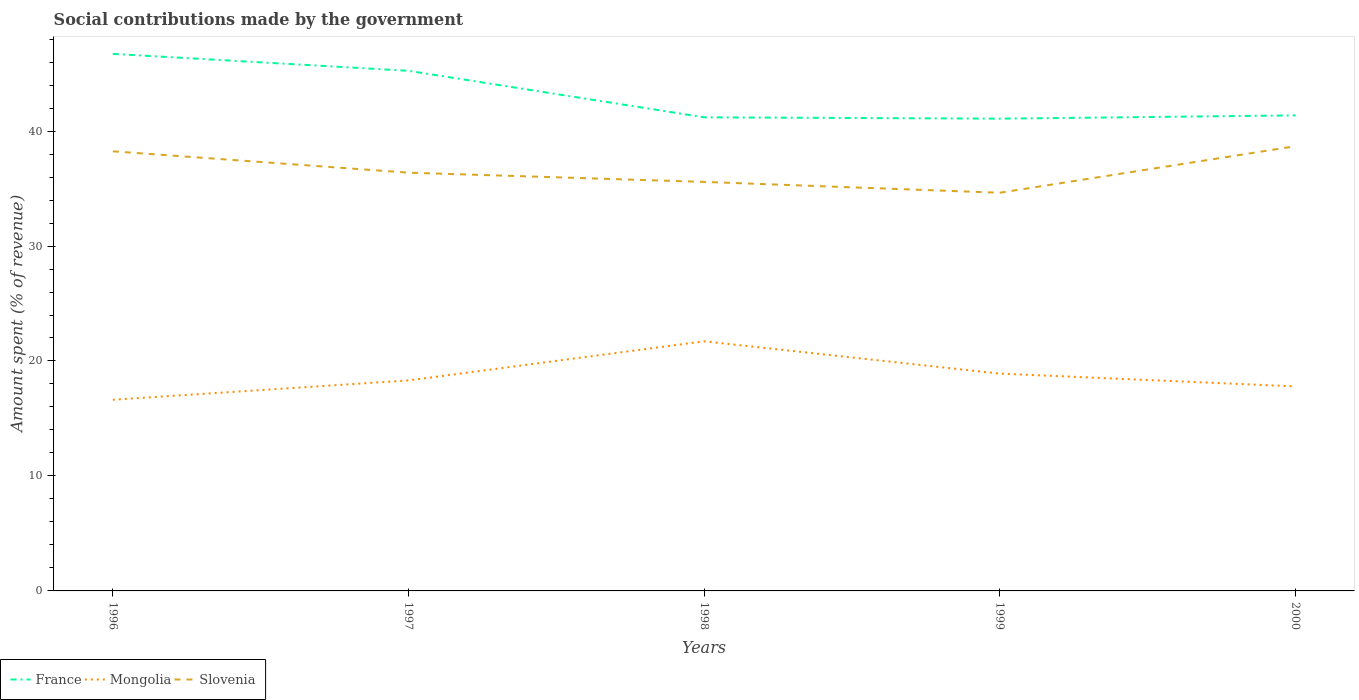Does the line corresponding to Mongolia intersect with the line corresponding to Slovenia?
Ensure brevity in your answer.  No. Is the number of lines equal to the number of legend labels?
Provide a succinct answer. Yes. Across all years, what is the maximum amount spent (in %) on social contributions in Mongolia?
Ensure brevity in your answer.  16.63. What is the total amount spent (in %) on social contributions in Mongolia in the graph?
Offer a very short reply. -1.68. What is the difference between the highest and the second highest amount spent (in %) on social contributions in Mongolia?
Make the answer very short. 5.08. What is the difference between the highest and the lowest amount spent (in %) on social contributions in France?
Give a very brief answer. 2. How many lines are there?
Keep it short and to the point. 3. How many years are there in the graph?
Your answer should be compact. 5. Are the values on the major ticks of Y-axis written in scientific E-notation?
Give a very brief answer. No. Does the graph contain any zero values?
Make the answer very short. No. Where does the legend appear in the graph?
Your answer should be compact. Bottom left. How many legend labels are there?
Your answer should be compact. 3. What is the title of the graph?
Your answer should be very brief. Social contributions made by the government. What is the label or title of the X-axis?
Your response must be concise. Years. What is the label or title of the Y-axis?
Provide a succinct answer. Amount spent (% of revenue). What is the Amount spent (% of revenue) in France in 1996?
Provide a short and direct response. 46.71. What is the Amount spent (% of revenue) of Mongolia in 1996?
Offer a very short reply. 16.63. What is the Amount spent (% of revenue) of Slovenia in 1996?
Ensure brevity in your answer.  38.24. What is the Amount spent (% of revenue) of France in 1997?
Offer a very short reply. 45.24. What is the Amount spent (% of revenue) of Mongolia in 1997?
Provide a succinct answer. 18.31. What is the Amount spent (% of revenue) of Slovenia in 1997?
Keep it short and to the point. 36.38. What is the Amount spent (% of revenue) of France in 1998?
Ensure brevity in your answer.  41.2. What is the Amount spent (% of revenue) of Mongolia in 1998?
Your response must be concise. 21.71. What is the Amount spent (% of revenue) in Slovenia in 1998?
Your response must be concise. 35.58. What is the Amount spent (% of revenue) of France in 1999?
Provide a short and direct response. 41.08. What is the Amount spent (% of revenue) of Mongolia in 1999?
Your response must be concise. 18.9. What is the Amount spent (% of revenue) in Slovenia in 1999?
Keep it short and to the point. 34.63. What is the Amount spent (% of revenue) in France in 2000?
Provide a succinct answer. 41.36. What is the Amount spent (% of revenue) of Mongolia in 2000?
Your answer should be very brief. 17.79. What is the Amount spent (% of revenue) in Slovenia in 2000?
Your answer should be compact. 38.68. Across all years, what is the maximum Amount spent (% of revenue) in France?
Provide a short and direct response. 46.71. Across all years, what is the maximum Amount spent (% of revenue) of Mongolia?
Your response must be concise. 21.71. Across all years, what is the maximum Amount spent (% of revenue) in Slovenia?
Your response must be concise. 38.68. Across all years, what is the minimum Amount spent (% of revenue) in France?
Ensure brevity in your answer.  41.08. Across all years, what is the minimum Amount spent (% of revenue) in Mongolia?
Make the answer very short. 16.63. Across all years, what is the minimum Amount spent (% of revenue) in Slovenia?
Ensure brevity in your answer.  34.63. What is the total Amount spent (% of revenue) of France in the graph?
Offer a terse response. 215.59. What is the total Amount spent (% of revenue) of Mongolia in the graph?
Offer a very short reply. 93.34. What is the total Amount spent (% of revenue) of Slovenia in the graph?
Offer a terse response. 183.51. What is the difference between the Amount spent (% of revenue) of France in 1996 and that in 1997?
Your answer should be compact. 1.47. What is the difference between the Amount spent (% of revenue) in Mongolia in 1996 and that in 1997?
Your response must be concise. -1.68. What is the difference between the Amount spent (% of revenue) in Slovenia in 1996 and that in 1997?
Offer a very short reply. 1.86. What is the difference between the Amount spent (% of revenue) in France in 1996 and that in 1998?
Your answer should be compact. 5.52. What is the difference between the Amount spent (% of revenue) in Mongolia in 1996 and that in 1998?
Keep it short and to the point. -5.08. What is the difference between the Amount spent (% of revenue) in Slovenia in 1996 and that in 1998?
Keep it short and to the point. 2.66. What is the difference between the Amount spent (% of revenue) of France in 1996 and that in 1999?
Your answer should be compact. 5.64. What is the difference between the Amount spent (% of revenue) in Mongolia in 1996 and that in 1999?
Offer a terse response. -2.27. What is the difference between the Amount spent (% of revenue) of Slovenia in 1996 and that in 1999?
Provide a short and direct response. 3.61. What is the difference between the Amount spent (% of revenue) in France in 1996 and that in 2000?
Your answer should be compact. 5.35. What is the difference between the Amount spent (% of revenue) in Mongolia in 1996 and that in 2000?
Provide a short and direct response. -1.16. What is the difference between the Amount spent (% of revenue) in Slovenia in 1996 and that in 2000?
Your answer should be compact. -0.44. What is the difference between the Amount spent (% of revenue) in France in 1997 and that in 1998?
Ensure brevity in your answer.  4.04. What is the difference between the Amount spent (% of revenue) of Mongolia in 1997 and that in 1998?
Your response must be concise. -3.4. What is the difference between the Amount spent (% of revenue) in Slovenia in 1997 and that in 1998?
Offer a very short reply. 0.8. What is the difference between the Amount spent (% of revenue) in France in 1997 and that in 1999?
Offer a terse response. 4.16. What is the difference between the Amount spent (% of revenue) in Mongolia in 1997 and that in 1999?
Provide a succinct answer. -0.59. What is the difference between the Amount spent (% of revenue) in Slovenia in 1997 and that in 1999?
Your answer should be very brief. 1.75. What is the difference between the Amount spent (% of revenue) in France in 1997 and that in 2000?
Ensure brevity in your answer.  3.88. What is the difference between the Amount spent (% of revenue) of Mongolia in 1997 and that in 2000?
Your response must be concise. 0.52. What is the difference between the Amount spent (% of revenue) of Slovenia in 1997 and that in 2000?
Ensure brevity in your answer.  -2.3. What is the difference between the Amount spent (% of revenue) in France in 1998 and that in 1999?
Make the answer very short. 0.12. What is the difference between the Amount spent (% of revenue) in Mongolia in 1998 and that in 1999?
Provide a succinct answer. 2.81. What is the difference between the Amount spent (% of revenue) in Slovenia in 1998 and that in 1999?
Give a very brief answer. 0.94. What is the difference between the Amount spent (% of revenue) in France in 1998 and that in 2000?
Make the answer very short. -0.17. What is the difference between the Amount spent (% of revenue) in Mongolia in 1998 and that in 2000?
Offer a terse response. 3.92. What is the difference between the Amount spent (% of revenue) of Slovenia in 1998 and that in 2000?
Ensure brevity in your answer.  -3.1. What is the difference between the Amount spent (% of revenue) in France in 1999 and that in 2000?
Ensure brevity in your answer.  -0.29. What is the difference between the Amount spent (% of revenue) in Mongolia in 1999 and that in 2000?
Ensure brevity in your answer.  1.11. What is the difference between the Amount spent (% of revenue) of Slovenia in 1999 and that in 2000?
Offer a terse response. -4.05. What is the difference between the Amount spent (% of revenue) of France in 1996 and the Amount spent (% of revenue) of Mongolia in 1997?
Your response must be concise. 28.4. What is the difference between the Amount spent (% of revenue) in France in 1996 and the Amount spent (% of revenue) in Slovenia in 1997?
Give a very brief answer. 10.33. What is the difference between the Amount spent (% of revenue) of Mongolia in 1996 and the Amount spent (% of revenue) of Slovenia in 1997?
Make the answer very short. -19.75. What is the difference between the Amount spent (% of revenue) in France in 1996 and the Amount spent (% of revenue) in Mongolia in 1998?
Your answer should be compact. 25. What is the difference between the Amount spent (% of revenue) in France in 1996 and the Amount spent (% of revenue) in Slovenia in 1998?
Provide a short and direct response. 11.14. What is the difference between the Amount spent (% of revenue) of Mongolia in 1996 and the Amount spent (% of revenue) of Slovenia in 1998?
Your response must be concise. -18.95. What is the difference between the Amount spent (% of revenue) of France in 1996 and the Amount spent (% of revenue) of Mongolia in 1999?
Make the answer very short. 27.81. What is the difference between the Amount spent (% of revenue) of France in 1996 and the Amount spent (% of revenue) of Slovenia in 1999?
Give a very brief answer. 12.08. What is the difference between the Amount spent (% of revenue) in Mongolia in 1996 and the Amount spent (% of revenue) in Slovenia in 1999?
Your answer should be very brief. -18.01. What is the difference between the Amount spent (% of revenue) in France in 1996 and the Amount spent (% of revenue) in Mongolia in 2000?
Ensure brevity in your answer.  28.92. What is the difference between the Amount spent (% of revenue) of France in 1996 and the Amount spent (% of revenue) of Slovenia in 2000?
Ensure brevity in your answer.  8.03. What is the difference between the Amount spent (% of revenue) in Mongolia in 1996 and the Amount spent (% of revenue) in Slovenia in 2000?
Provide a short and direct response. -22.05. What is the difference between the Amount spent (% of revenue) in France in 1997 and the Amount spent (% of revenue) in Mongolia in 1998?
Provide a short and direct response. 23.53. What is the difference between the Amount spent (% of revenue) of France in 1997 and the Amount spent (% of revenue) of Slovenia in 1998?
Give a very brief answer. 9.66. What is the difference between the Amount spent (% of revenue) in Mongolia in 1997 and the Amount spent (% of revenue) in Slovenia in 1998?
Make the answer very short. -17.27. What is the difference between the Amount spent (% of revenue) of France in 1997 and the Amount spent (% of revenue) of Mongolia in 1999?
Your response must be concise. 26.34. What is the difference between the Amount spent (% of revenue) in France in 1997 and the Amount spent (% of revenue) in Slovenia in 1999?
Provide a succinct answer. 10.61. What is the difference between the Amount spent (% of revenue) of Mongolia in 1997 and the Amount spent (% of revenue) of Slovenia in 1999?
Offer a terse response. -16.32. What is the difference between the Amount spent (% of revenue) in France in 1997 and the Amount spent (% of revenue) in Mongolia in 2000?
Your answer should be very brief. 27.45. What is the difference between the Amount spent (% of revenue) of France in 1997 and the Amount spent (% of revenue) of Slovenia in 2000?
Keep it short and to the point. 6.56. What is the difference between the Amount spent (% of revenue) of Mongolia in 1997 and the Amount spent (% of revenue) of Slovenia in 2000?
Offer a terse response. -20.37. What is the difference between the Amount spent (% of revenue) of France in 1998 and the Amount spent (% of revenue) of Mongolia in 1999?
Ensure brevity in your answer.  22.29. What is the difference between the Amount spent (% of revenue) in France in 1998 and the Amount spent (% of revenue) in Slovenia in 1999?
Keep it short and to the point. 6.56. What is the difference between the Amount spent (% of revenue) of Mongolia in 1998 and the Amount spent (% of revenue) of Slovenia in 1999?
Provide a short and direct response. -12.92. What is the difference between the Amount spent (% of revenue) in France in 1998 and the Amount spent (% of revenue) in Mongolia in 2000?
Your response must be concise. 23.41. What is the difference between the Amount spent (% of revenue) in France in 1998 and the Amount spent (% of revenue) in Slovenia in 2000?
Provide a succinct answer. 2.51. What is the difference between the Amount spent (% of revenue) in Mongolia in 1998 and the Amount spent (% of revenue) in Slovenia in 2000?
Make the answer very short. -16.97. What is the difference between the Amount spent (% of revenue) of France in 1999 and the Amount spent (% of revenue) of Mongolia in 2000?
Provide a succinct answer. 23.29. What is the difference between the Amount spent (% of revenue) of France in 1999 and the Amount spent (% of revenue) of Slovenia in 2000?
Your answer should be compact. 2.4. What is the difference between the Amount spent (% of revenue) in Mongolia in 1999 and the Amount spent (% of revenue) in Slovenia in 2000?
Your answer should be compact. -19.78. What is the average Amount spent (% of revenue) of France per year?
Ensure brevity in your answer.  43.12. What is the average Amount spent (% of revenue) in Mongolia per year?
Ensure brevity in your answer.  18.67. What is the average Amount spent (% of revenue) in Slovenia per year?
Your answer should be compact. 36.7. In the year 1996, what is the difference between the Amount spent (% of revenue) of France and Amount spent (% of revenue) of Mongolia?
Give a very brief answer. 30.09. In the year 1996, what is the difference between the Amount spent (% of revenue) in France and Amount spent (% of revenue) in Slovenia?
Provide a succinct answer. 8.47. In the year 1996, what is the difference between the Amount spent (% of revenue) of Mongolia and Amount spent (% of revenue) of Slovenia?
Give a very brief answer. -21.61. In the year 1997, what is the difference between the Amount spent (% of revenue) of France and Amount spent (% of revenue) of Mongolia?
Offer a terse response. 26.93. In the year 1997, what is the difference between the Amount spent (% of revenue) of France and Amount spent (% of revenue) of Slovenia?
Your response must be concise. 8.86. In the year 1997, what is the difference between the Amount spent (% of revenue) of Mongolia and Amount spent (% of revenue) of Slovenia?
Give a very brief answer. -18.07. In the year 1998, what is the difference between the Amount spent (% of revenue) in France and Amount spent (% of revenue) in Mongolia?
Your answer should be compact. 19.49. In the year 1998, what is the difference between the Amount spent (% of revenue) in France and Amount spent (% of revenue) in Slovenia?
Your response must be concise. 5.62. In the year 1998, what is the difference between the Amount spent (% of revenue) of Mongolia and Amount spent (% of revenue) of Slovenia?
Your answer should be very brief. -13.87. In the year 1999, what is the difference between the Amount spent (% of revenue) of France and Amount spent (% of revenue) of Mongolia?
Provide a short and direct response. 22.18. In the year 1999, what is the difference between the Amount spent (% of revenue) of France and Amount spent (% of revenue) of Slovenia?
Offer a terse response. 6.44. In the year 1999, what is the difference between the Amount spent (% of revenue) in Mongolia and Amount spent (% of revenue) in Slovenia?
Give a very brief answer. -15.73. In the year 2000, what is the difference between the Amount spent (% of revenue) of France and Amount spent (% of revenue) of Mongolia?
Offer a terse response. 23.57. In the year 2000, what is the difference between the Amount spent (% of revenue) in France and Amount spent (% of revenue) in Slovenia?
Ensure brevity in your answer.  2.68. In the year 2000, what is the difference between the Amount spent (% of revenue) in Mongolia and Amount spent (% of revenue) in Slovenia?
Offer a terse response. -20.89. What is the ratio of the Amount spent (% of revenue) of France in 1996 to that in 1997?
Keep it short and to the point. 1.03. What is the ratio of the Amount spent (% of revenue) of Mongolia in 1996 to that in 1997?
Your response must be concise. 0.91. What is the ratio of the Amount spent (% of revenue) of Slovenia in 1996 to that in 1997?
Keep it short and to the point. 1.05. What is the ratio of the Amount spent (% of revenue) in France in 1996 to that in 1998?
Ensure brevity in your answer.  1.13. What is the ratio of the Amount spent (% of revenue) of Mongolia in 1996 to that in 1998?
Give a very brief answer. 0.77. What is the ratio of the Amount spent (% of revenue) in Slovenia in 1996 to that in 1998?
Your response must be concise. 1.07. What is the ratio of the Amount spent (% of revenue) in France in 1996 to that in 1999?
Make the answer very short. 1.14. What is the ratio of the Amount spent (% of revenue) of Mongolia in 1996 to that in 1999?
Provide a short and direct response. 0.88. What is the ratio of the Amount spent (% of revenue) of Slovenia in 1996 to that in 1999?
Offer a terse response. 1.1. What is the ratio of the Amount spent (% of revenue) in France in 1996 to that in 2000?
Give a very brief answer. 1.13. What is the ratio of the Amount spent (% of revenue) of Mongolia in 1996 to that in 2000?
Provide a short and direct response. 0.93. What is the ratio of the Amount spent (% of revenue) of Slovenia in 1996 to that in 2000?
Your answer should be very brief. 0.99. What is the ratio of the Amount spent (% of revenue) in France in 1997 to that in 1998?
Offer a very short reply. 1.1. What is the ratio of the Amount spent (% of revenue) of Mongolia in 1997 to that in 1998?
Make the answer very short. 0.84. What is the ratio of the Amount spent (% of revenue) of Slovenia in 1997 to that in 1998?
Make the answer very short. 1.02. What is the ratio of the Amount spent (% of revenue) of France in 1997 to that in 1999?
Give a very brief answer. 1.1. What is the ratio of the Amount spent (% of revenue) of Mongolia in 1997 to that in 1999?
Provide a succinct answer. 0.97. What is the ratio of the Amount spent (% of revenue) of Slovenia in 1997 to that in 1999?
Make the answer very short. 1.05. What is the ratio of the Amount spent (% of revenue) of France in 1997 to that in 2000?
Ensure brevity in your answer.  1.09. What is the ratio of the Amount spent (% of revenue) of Mongolia in 1997 to that in 2000?
Your answer should be very brief. 1.03. What is the ratio of the Amount spent (% of revenue) of Slovenia in 1997 to that in 2000?
Provide a short and direct response. 0.94. What is the ratio of the Amount spent (% of revenue) of France in 1998 to that in 1999?
Your response must be concise. 1. What is the ratio of the Amount spent (% of revenue) of Mongolia in 1998 to that in 1999?
Provide a succinct answer. 1.15. What is the ratio of the Amount spent (% of revenue) in Slovenia in 1998 to that in 1999?
Offer a terse response. 1.03. What is the ratio of the Amount spent (% of revenue) in Mongolia in 1998 to that in 2000?
Offer a terse response. 1.22. What is the ratio of the Amount spent (% of revenue) in Slovenia in 1998 to that in 2000?
Your answer should be very brief. 0.92. What is the ratio of the Amount spent (% of revenue) of France in 1999 to that in 2000?
Provide a short and direct response. 0.99. What is the ratio of the Amount spent (% of revenue) in Slovenia in 1999 to that in 2000?
Provide a short and direct response. 0.9. What is the difference between the highest and the second highest Amount spent (% of revenue) of France?
Provide a short and direct response. 1.47. What is the difference between the highest and the second highest Amount spent (% of revenue) in Mongolia?
Offer a very short reply. 2.81. What is the difference between the highest and the second highest Amount spent (% of revenue) of Slovenia?
Your response must be concise. 0.44. What is the difference between the highest and the lowest Amount spent (% of revenue) of France?
Keep it short and to the point. 5.64. What is the difference between the highest and the lowest Amount spent (% of revenue) in Mongolia?
Provide a succinct answer. 5.08. What is the difference between the highest and the lowest Amount spent (% of revenue) of Slovenia?
Provide a succinct answer. 4.05. 